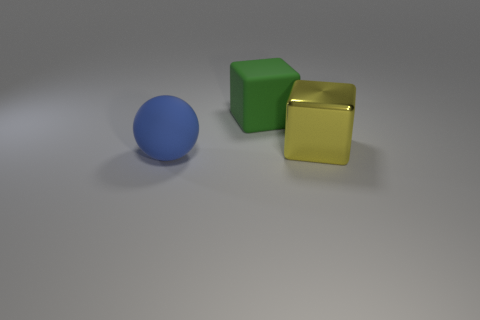Can you describe the lighting and shadows in this scene? The lighting in the scene is soft and diffused, suggesting an ambient light source. It creates gentle shadows that fall to the right of the objects, indicating that the primary light source comes from the left. The shadows offer a sense of depth to the image, allowing us to perceive the three-dimensional forms of the objects more distinctly. 